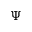<formula> <loc_0><loc_0><loc_500><loc_500>\Psi</formula> 